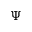<formula> <loc_0><loc_0><loc_500><loc_500>\Psi</formula> 